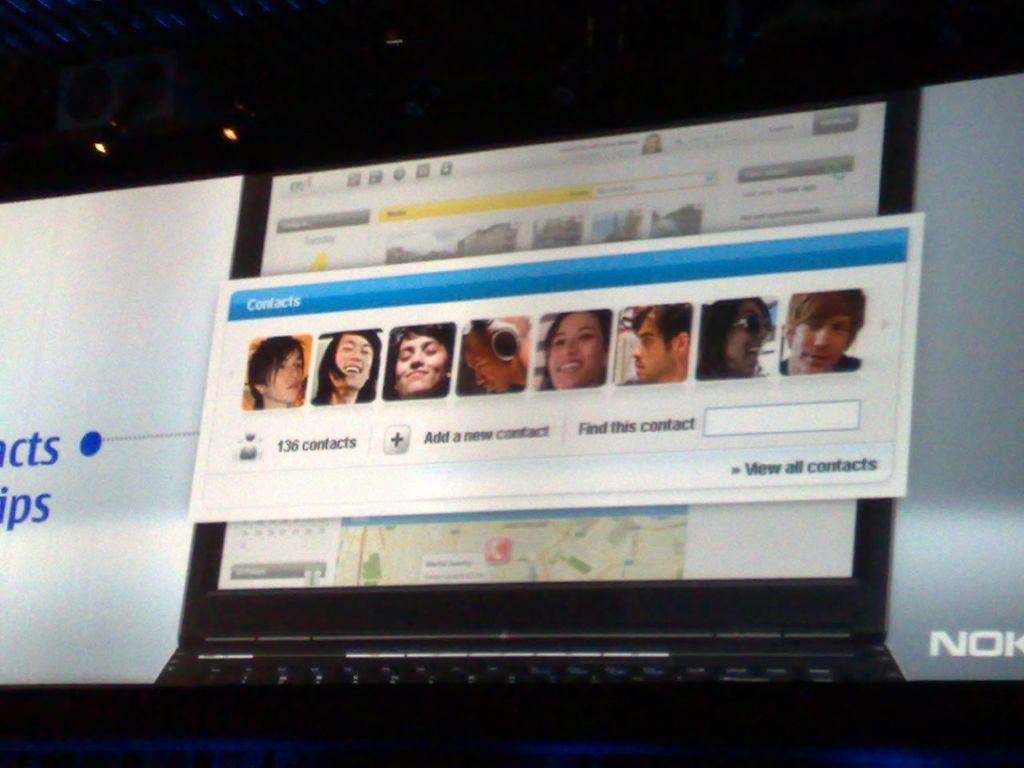<image>
Relay a brief, clear account of the picture shown. A pop up window provides an option to add a new contact or to find a specific contact, as well as view all contacts. 